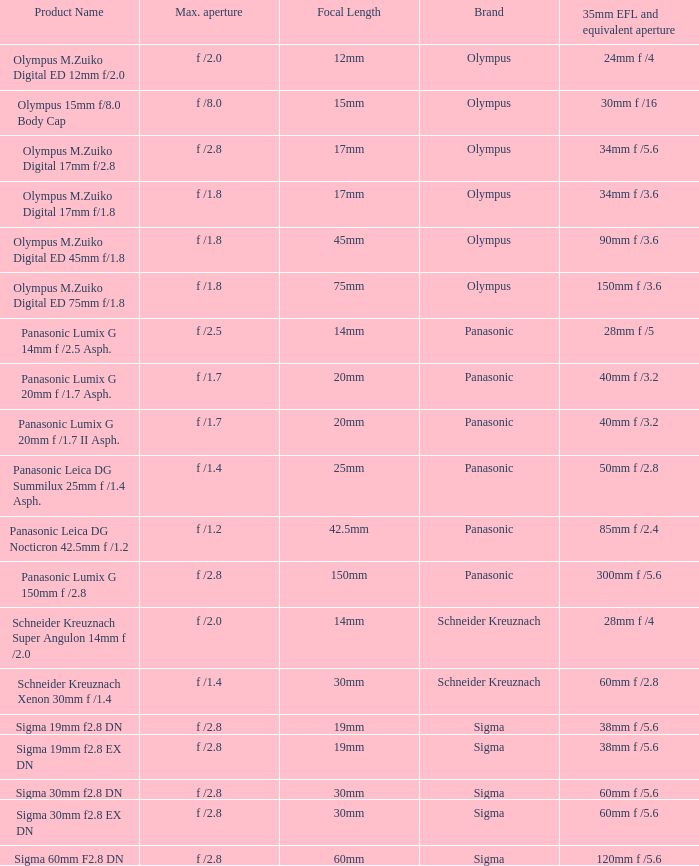What is the 35mm EFL and the equivalent aperture of the lens(es) with a maximum aperture of f /2.5? 28mm f /5. 